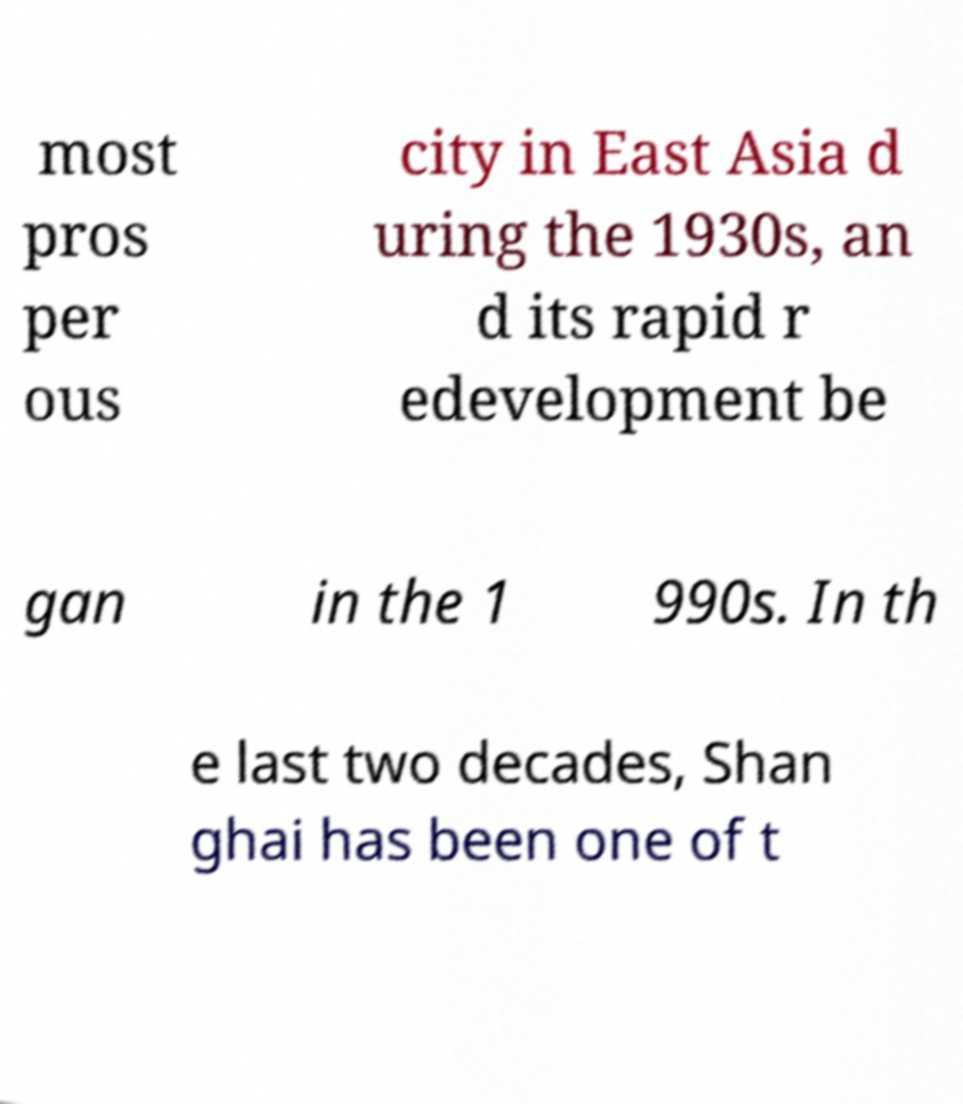For documentation purposes, I need the text within this image transcribed. Could you provide that? most pros per ous city in East Asia d uring the 1930s, an d its rapid r edevelopment be gan in the 1 990s. In th e last two decades, Shan ghai has been one of t 